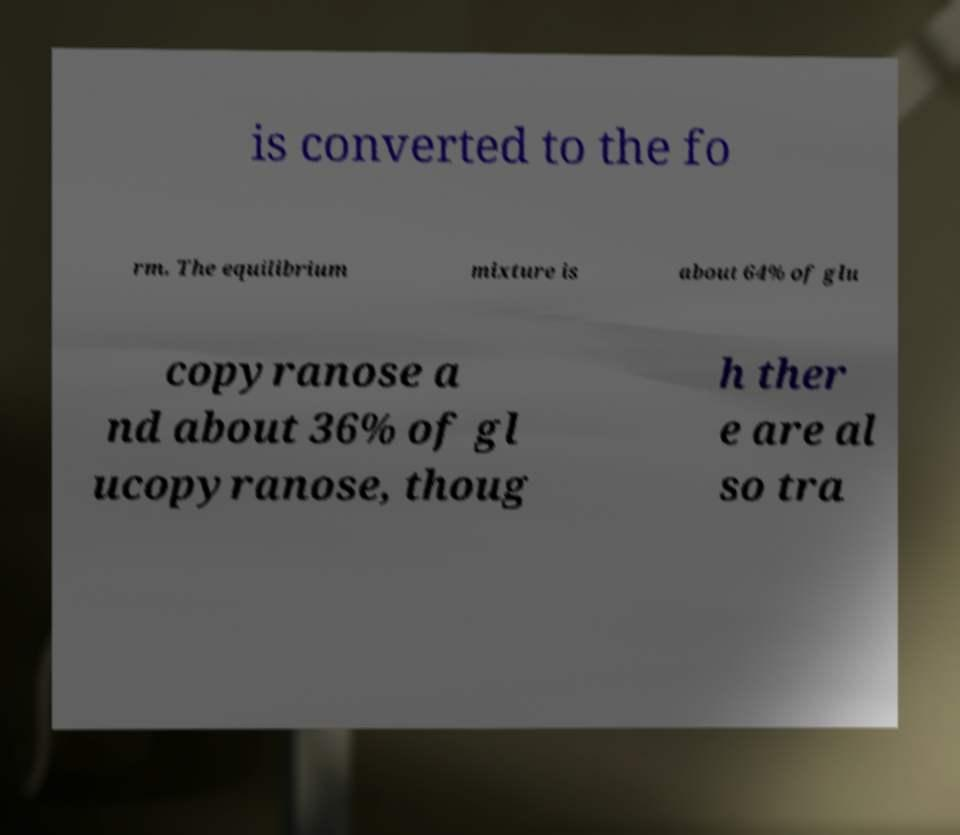Please read and relay the text visible in this image. What does it say? is converted to the fo rm. The equilibrium mixture is about 64% of glu copyranose a nd about 36% of gl ucopyranose, thoug h ther e are al so tra 